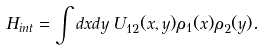Convert formula to latex. <formula><loc_0><loc_0><loc_500><loc_500>H _ { i n t } = \int d x d y \, U _ { 1 2 } ( x , y ) \rho _ { 1 } ( x ) \rho _ { 2 } ( y ) .</formula> 